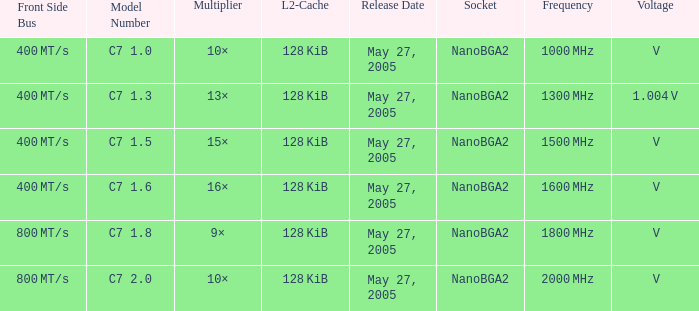What is the Frequency for Model Number c7 1.0? 1000 MHz. 